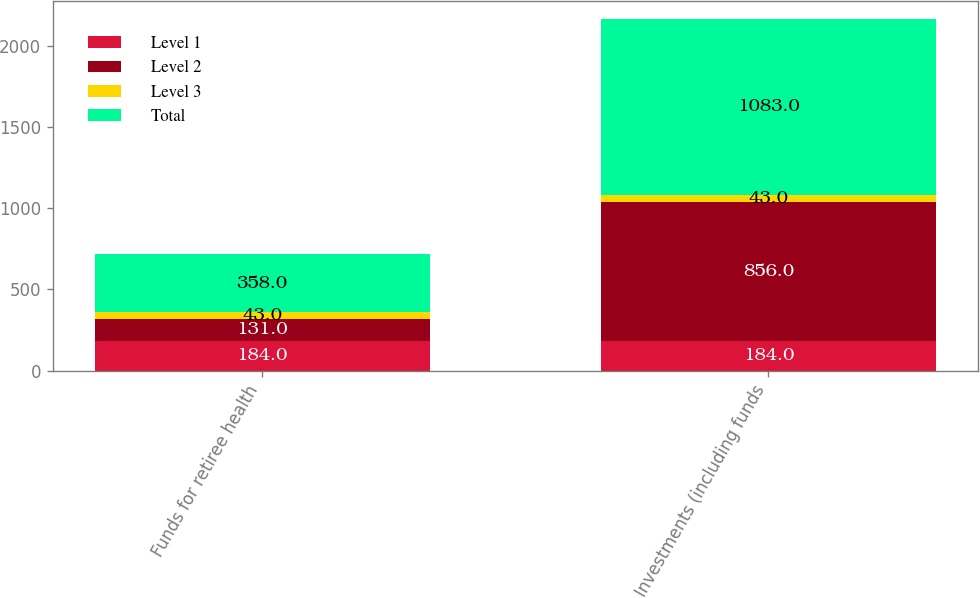Convert chart to OTSL. <chart><loc_0><loc_0><loc_500><loc_500><stacked_bar_chart><ecel><fcel>Funds for retiree health<fcel>Investments (including funds<nl><fcel>Level 1<fcel>184<fcel>184<nl><fcel>Level 2<fcel>131<fcel>856<nl><fcel>Level 3<fcel>43<fcel>43<nl><fcel>Total<fcel>358<fcel>1083<nl></chart> 